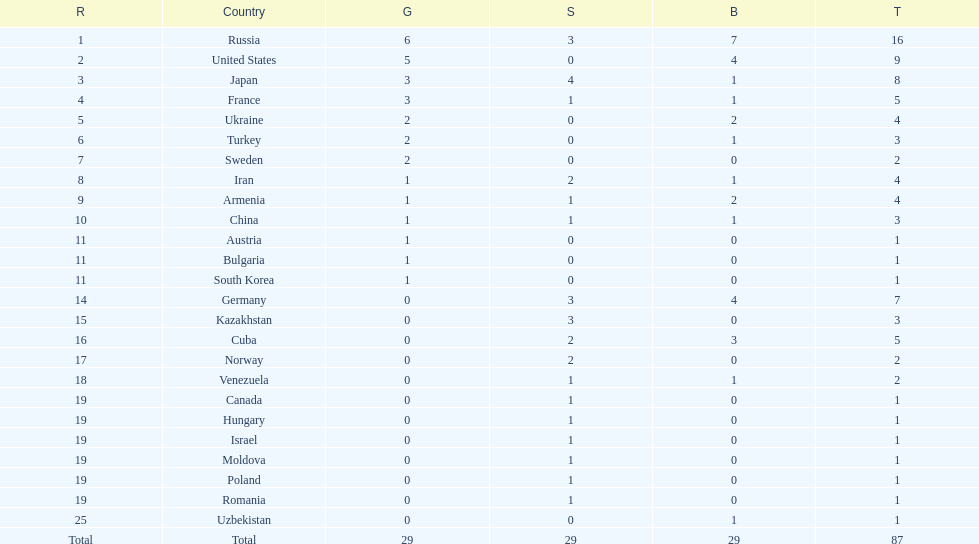Which country won only one medal, a bronze medal? Uzbekistan. 